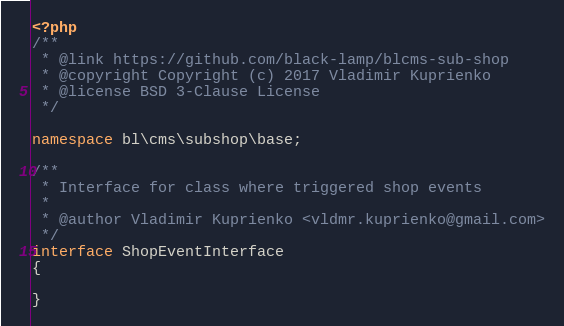Convert code to text. <code><loc_0><loc_0><loc_500><loc_500><_PHP_><?php
/**
 * @link https://github.com/black-lamp/blcms-sub-shop
 * @copyright Copyright (c) 2017 Vladimir Kuprienko
 * @license BSD 3-Clause License
 */

namespace bl\cms\subshop\base;

/**
 * Interface for class where triggered shop events
 *
 * @author Vladimir Kuprienko <vldmr.kuprienko@gmail.com>
 */
interface ShopEventInterface
{

}</code> 